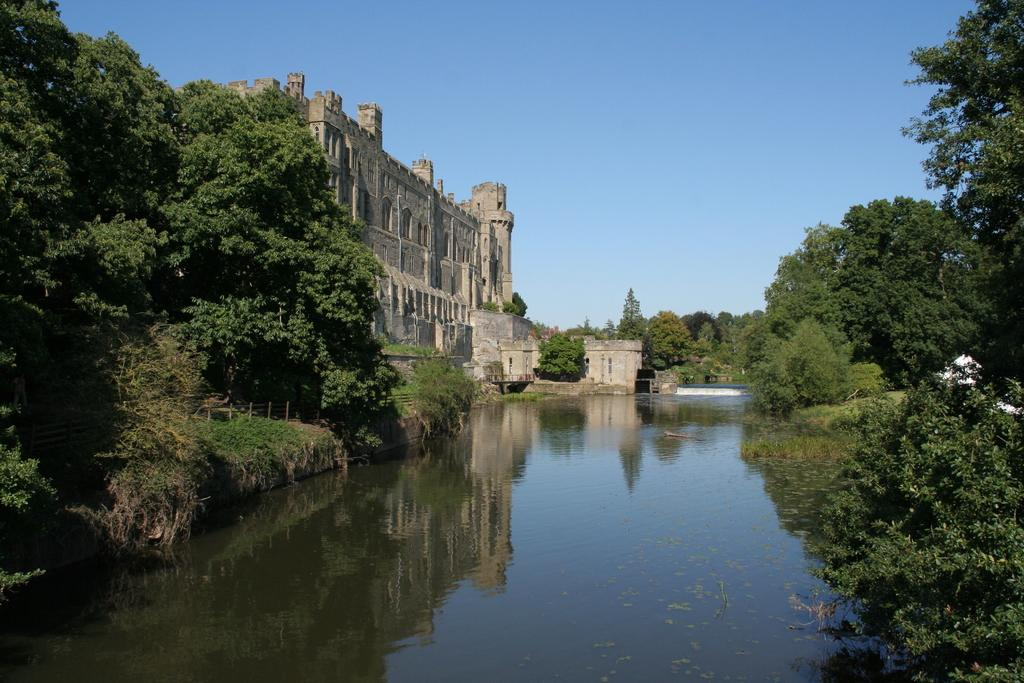What type of natural feature is present in the image? There is a river in the image. What type of man-made structure can be seen in the image? There is a building in the image. What connects the two sides of the river in the image? There is a bridge in the image. What type of vegetation is on the right side of the image? There are trees on the right side of the image. What is visible behind the building in the image? The sky is visible behind the building. What brand of toothpaste is advertised on the building in the image? There is no toothpaste or advertisement present on the building in the image. What type of knowledge can be gained from observing the river in the image? The image is not meant to convey any specific knowledge or information; it is simply a visual representation of a river, building, bridge, trees, and sky. 